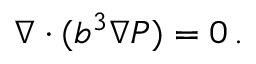<formula> <loc_0><loc_0><loc_500><loc_500>\nabla \cdot ( b ^ { 3 } \nabla P ) = 0 \, .</formula> 